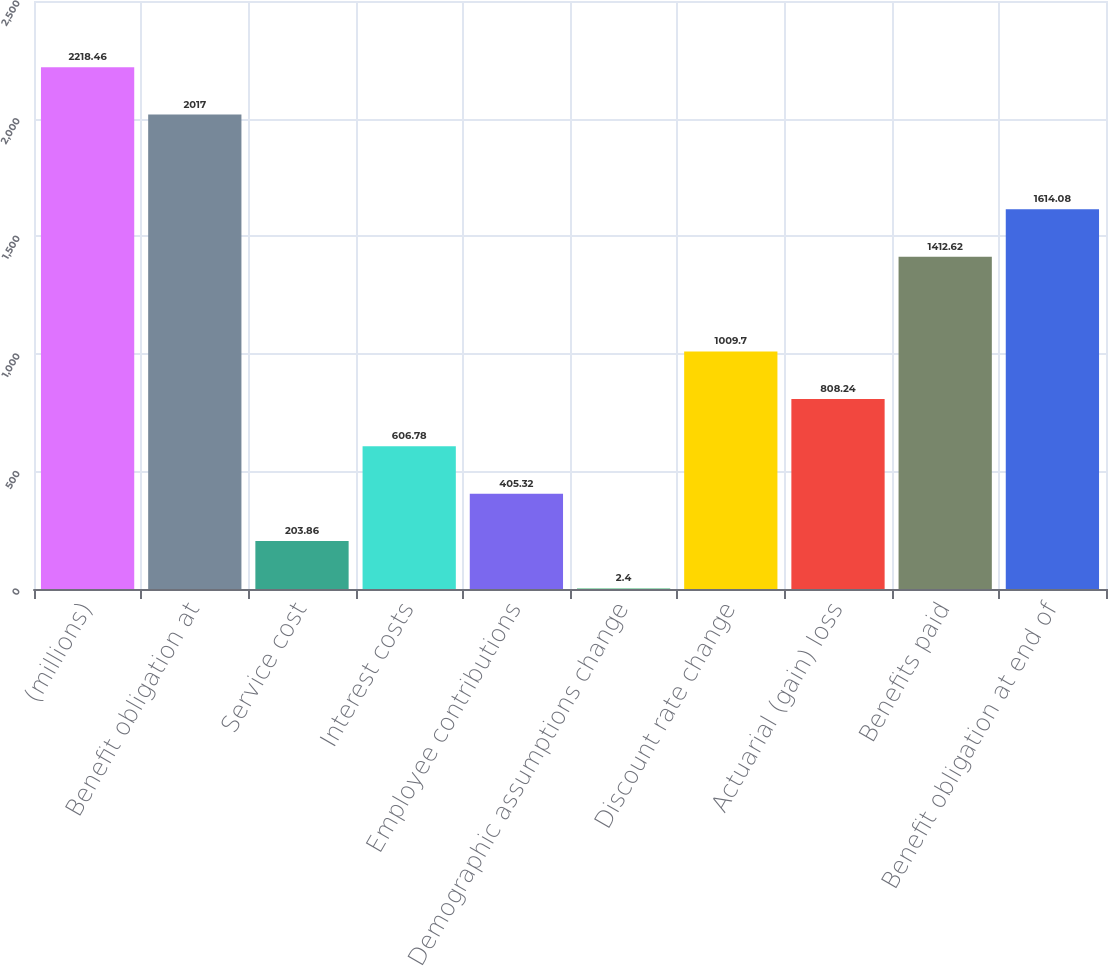Convert chart to OTSL. <chart><loc_0><loc_0><loc_500><loc_500><bar_chart><fcel>(millions)<fcel>Benefit obligation at<fcel>Service cost<fcel>Interest costs<fcel>Employee contributions<fcel>Demographic assumptions change<fcel>Discount rate change<fcel>Actuarial (gain) loss<fcel>Benefits paid<fcel>Benefit obligation at end of<nl><fcel>2218.46<fcel>2017<fcel>203.86<fcel>606.78<fcel>405.32<fcel>2.4<fcel>1009.7<fcel>808.24<fcel>1412.62<fcel>1614.08<nl></chart> 